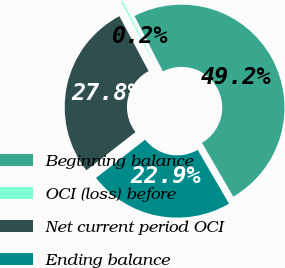Convert chart. <chart><loc_0><loc_0><loc_500><loc_500><pie_chart><fcel>Beginning balance<fcel>OCI (loss) before<fcel>Net current period OCI<fcel>Ending balance<nl><fcel>49.17%<fcel>0.21%<fcel>27.76%<fcel>22.86%<nl></chart> 